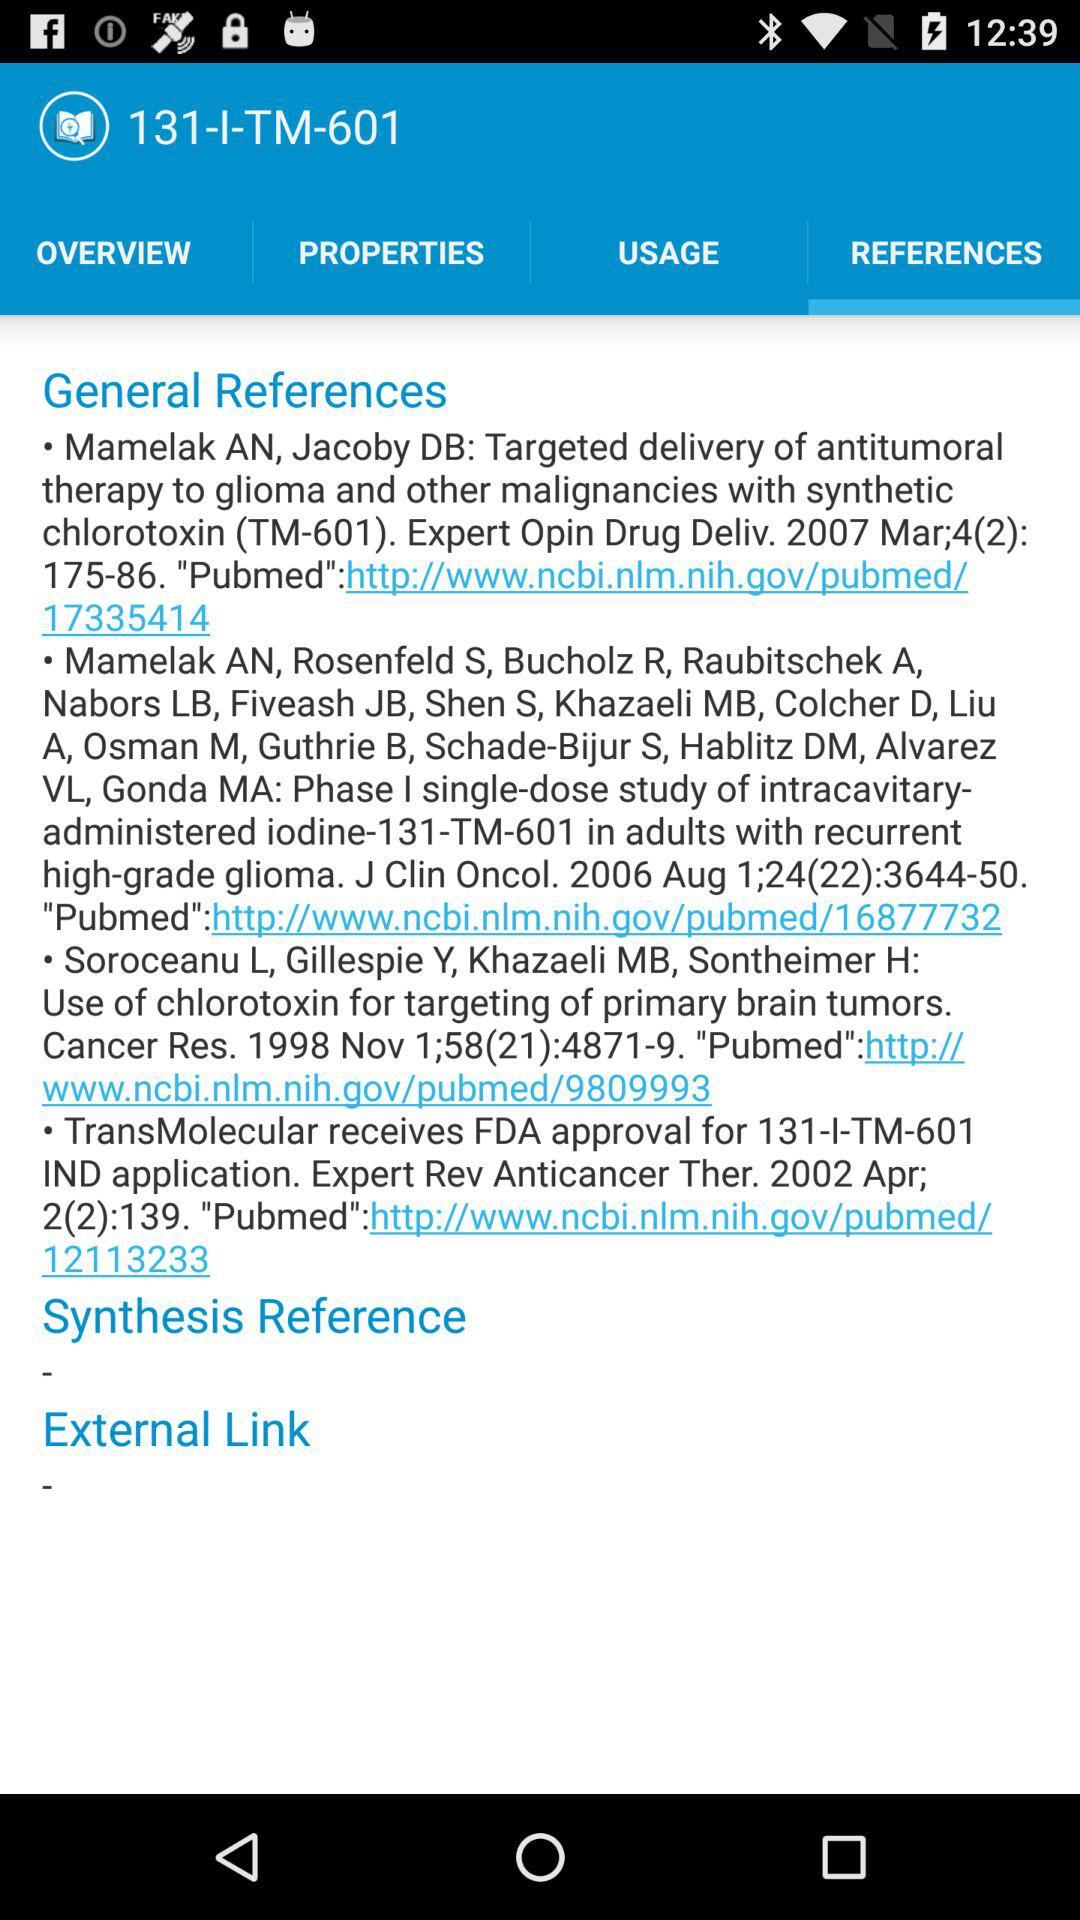Which tab is selected? The selected tab is "REFERENCES". 